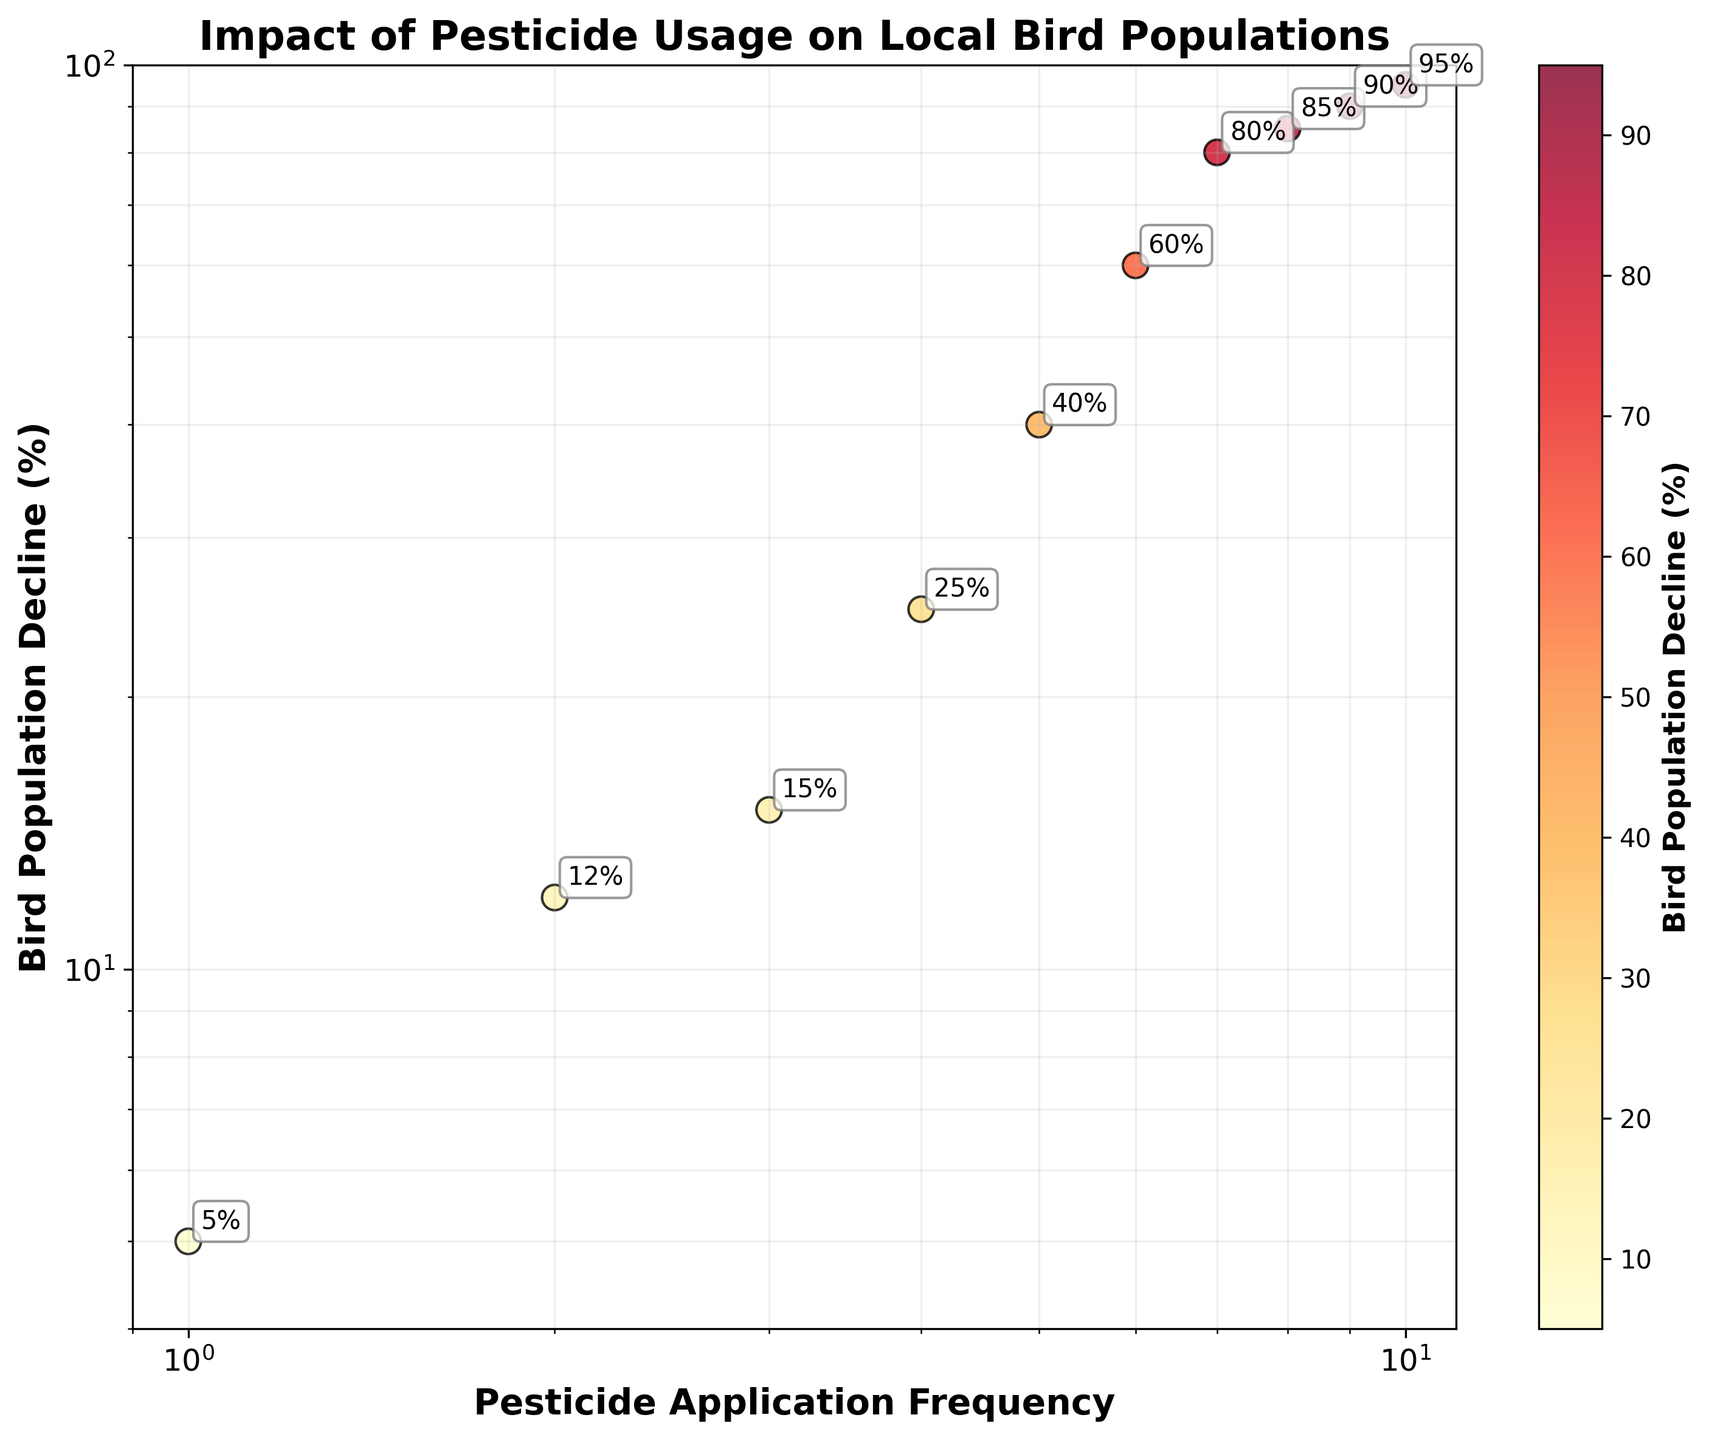What is the title of the scatter plot? The title is usually found at the top of the plot.
Answer: Impact of Pesticide Usage on Local Bird Populations Which two variables are represented on the axes? Look at the labels on the X-axis and Y-axis.
Answer: Pesticide Application Frequency and Bird Population Decline (%) How many data points are displayed in the plot? Count the individual points plotted on the scatter plot.
Answer: 10 What is the color scheme used to represent the data points? Observe the colors of the data points and the color bar.
Answer: Yellow to Red What is the range of the X-axis on the plot? Check the tick marks and the labeling on the X-axis.
Answer: 0.9 to 11 What is the range of the Y-axis on the plot? Check the tick marks and the labeling on the Y-axis.
Answer: 4 to 100 Which data point shows the highest bird population decline? Identify the point with the highest Y-axis value.
Answer: 95% Which data point has the lowest pesticide application frequency? Identify the point with the lowest X-axis value.
Answer: 1 What trend can you observe between pesticide application frequency and bird population decline? Look at the pattern formed by the data points from left to right.
Answer: Positive correlation What is the y-value for the data point with an x-value of 5? Locate the point on the plot where the X-axis value is 5 and read the corresponding Y-axis value.
Answer: 40% 